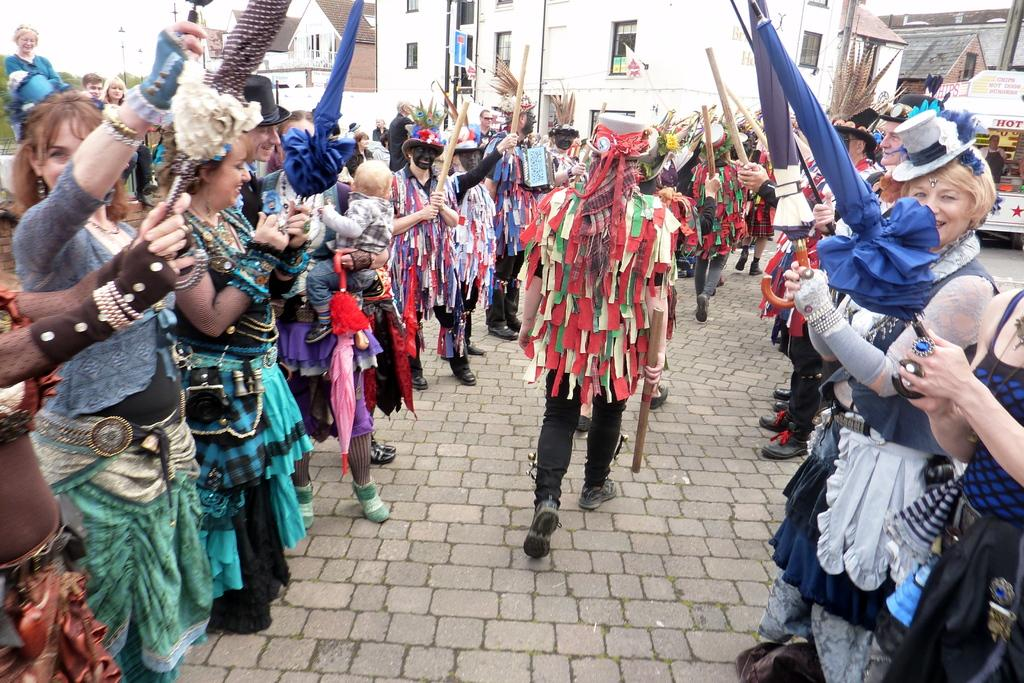What are the people in the image wearing? There are many persons with costumes in the image. Where are the people located in the image? The persons are on the road. What can be seen in the background of the image? There are buildings, trees, and the sky visible in the background of the image. What type of cheese is being used as a prop in the image? There is no cheese present in the image. How does the behavior of the persons in the image compare to that of a circle? The persons in the image are not behaving like a circle, as a circle is a geometric shape and not a behavior. 